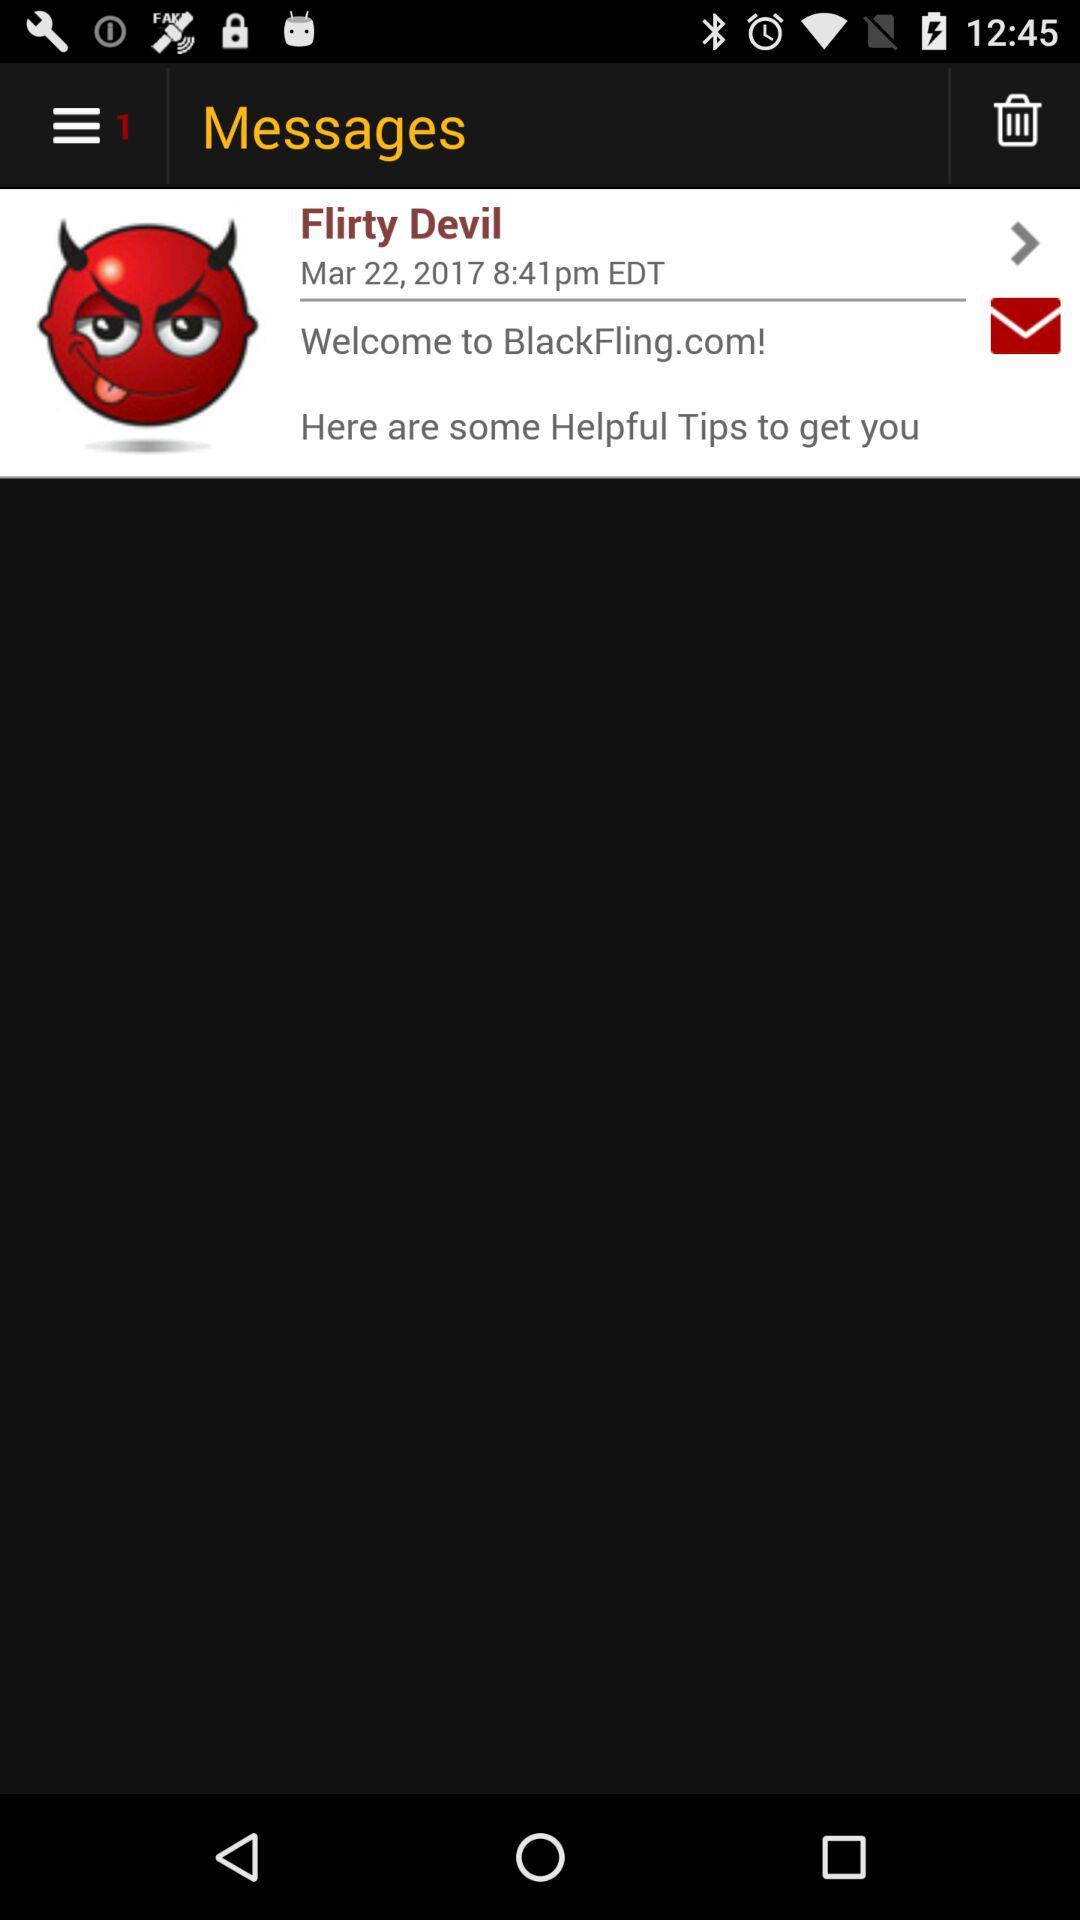What is the time? The time is 8:41 p.m. 